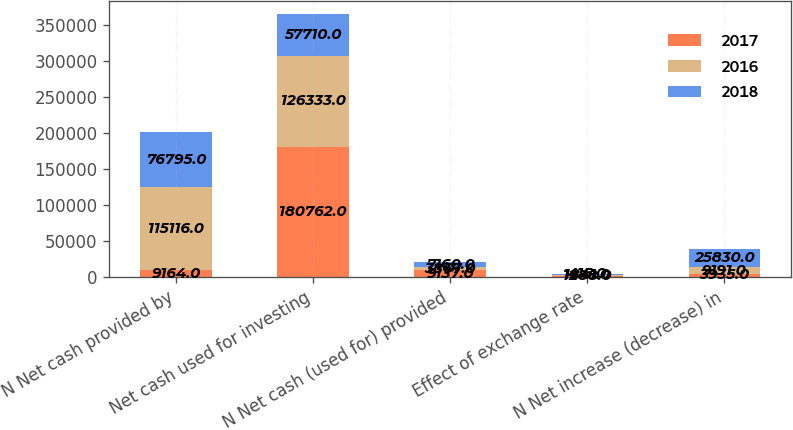<chart> <loc_0><loc_0><loc_500><loc_500><stacked_bar_chart><ecel><fcel>N Net cash provided by<fcel>Net cash used for investing<fcel>N Net cash (used for) provided<fcel>Effect of exchange rate<fcel>N Net increase (decrease) in<nl><fcel>2017<fcel>9164<fcel>180762<fcel>9137<fcel>1288<fcel>3935<nl><fcel>2016<fcel>115116<fcel>126333<fcel>3867<fcel>1841<fcel>9191<nl><fcel>2018<fcel>76795<fcel>57710<fcel>7160<fcel>415<fcel>25830<nl></chart> 